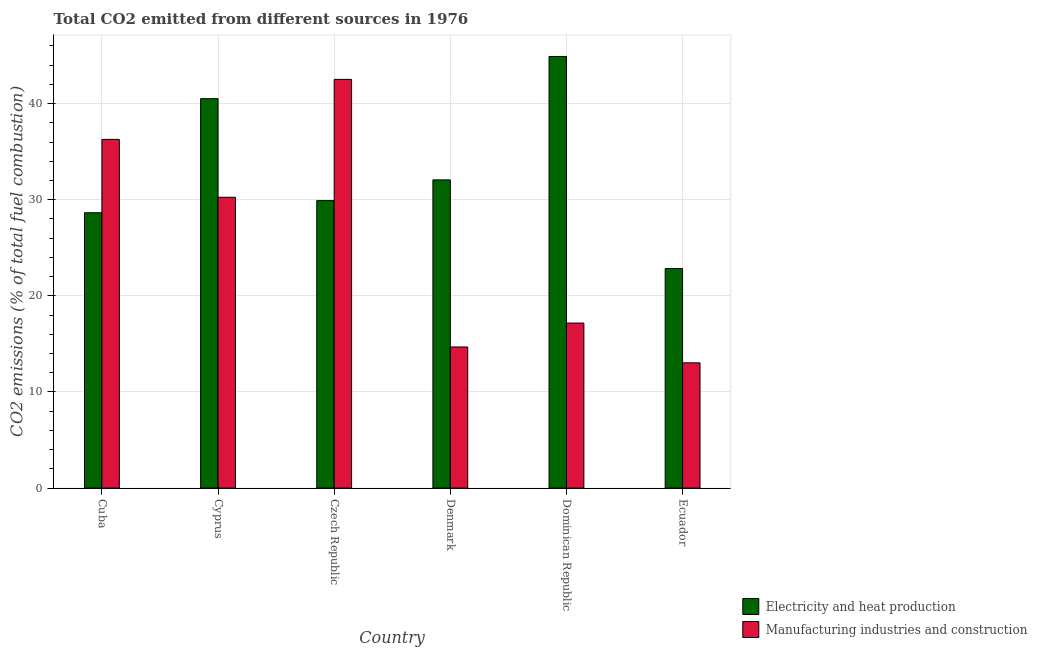How many different coloured bars are there?
Give a very brief answer. 2. How many groups of bars are there?
Ensure brevity in your answer.  6. Are the number of bars per tick equal to the number of legend labels?
Your answer should be compact. Yes. Are the number of bars on each tick of the X-axis equal?
Give a very brief answer. Yes. How many bars are there on the 6th tick from the left?
Offer a very short reply. 2. What is the label of the 4th group of bars from the left?
Your answer should be compact. Denmark. In how many cases, is the number of bars for a given country not equal to the number of legend labels?
Provide a succinct answer. 0. What is the co2 emissions due to electricity and heat production in Cuba?
Ensure brevity in your answer.  28.65. Across all countries, what is the maximum co2 emissions due to manufacturing industries?
Keep it short and to the point. 42.52. Across all countries, what is the minimum co2 emissions due to electricity and heat production?
Keep it short and to the point. 22.84. In which country was the co2 emissions due to electricity and heat production maximum?
Provide a short and direct response. Dominican Republic. In which country was the co2 emissions due to manufacturing industries minimum?
Ensure brevity in your answer.  Ecuador. What is the total co2 emissions due to electricity and heat production in the graph?
Your answer should be compact. 198.88. What is the difference between the co2 emissions due to electricity and heat production in Cyprus and that in Denmark?
Give a very brief answer. 8.45. What is the difference between the co2 emissions due to manufacturing industries in Denmark and the co2 emissions due to electricity and heat production in Dominican Republic?
Provide a short and direct response. -30.22. What is the average co2 emissions due to manufacturing industries per country?
Provide a succinct answer. 25.66. What is the difference between the co2 emissions due to manufacturing industries and co2 emissions due to electricity and heat production in Denmark?
Provide a succinct answer. -17.38. In how many countries, is the co2 emissions due to manufacturing industries greater than 42 %?
Your answer should be very brief. 1. What is the ratio of the co2 emissions due to manufacturing industries in Cyprus to that in Denmark?
Offer a terse response. 2.06. What is the difference between the highest and the second highest co2 emissions due to manufacturing industries?
Offer a very short reply. 6.24. What is the difference between the highest and the lowest co2 emissions due to electricity and heat production?
Your response must be concise. 22.07. What does the 2nd bar from the left in Dominican Republic represents?
Make the answer very short. Manufacturing industries and construction. What does the 1st bar from the right in Cyprus represents?
Your answer should be very brief. Manufacturing industries and construction. Are all the bars in the graph horizontal?
Provide a succinct answer. No. How many countries are there in the graph?
Your response must be concise. 6. What is the difference between two consecutive major ticks on the Y-axis?
Give a very brief answer. 10. Does the graph contain any zero values?
Offer a very short reply. No. Does the graph contain grids?
Offer a very short reply. Yes. Where does the legend appear in the graph?
Provide a short and direct response. Bottom right. How are the legend labels stacked?
Offer a very short reply. Vertical. What is the title of the graph?
Your answer should be compact. Total CO2 emitted from different sources in 1976. What is the label or title of the Y-axis?
Offer a terse response. CO2 emissions (% of total fuel combustion). What is the CO2 emissions (% of total fuel combustion) of Electricity and heat production in Cuba?
Provide a short and direct response. 28.65. What is the CO2 emissions (% of total fuel combustion) in Manufacturing industries and construction in Cuba?
Give a very brief answer. 36.28. What is the CO2 emissions (% of total fuel combustion) of Electricity and heat production in Cyprus?
Your answer should be very brief. 40.51. What is the CO2 emissions (% of total fuel combustion) in Manufacturing industries and construction in Cyprus?
Your answer should be compact. 30.26. What is the CO2 emissions (% of total fuel combustion) of Electricity and heat production in Czech Republic?
Your answer should be very brief. 29.91. What is the CO2 emissions (% of total fuel combustion) in Manufacturing industries and construction in Czech Republic?
Give a very brief answer. 42.52. What is the CO2 emissions (% of total fuel combustion) in Electricity and heat production in Denmark?
Your answer should be compact. 32.07. What is the CO2 emissions (% of total fuel combustion) of Manufacturing industries and construction in Denmark?
Give a very brief answer. 14.68. What is the CO2 emissions (% of total fuel combustion) of Electricity and heat production in Dominican Republic?
Your answer should be very brief. 44.91. What is the CO2 emissions (% of total fuel combustion) in Manufacturing industries and construction in Dominican Republic?
Your answer should be very brief. 17.17. What is the CO2 emissions (% of total fuel combustion) of Electricity and heat production in Ecuador?
Offer a very short reply. 22.84. What is the CO2 emissions (% of total fuel combustion) in Manufacturing industries and construction in Ecuador?
Make the answer very short. 13.03. Across all countries, what is the maximum CO2 emissions (% of total fuel combustion) of Electricity and heat production?
Offer a terse response. 44.91. Across all countries, what is the maximum CO2 emissions (% of total fuel combustion) in Manufacturing industries and construction?
Your answer should be compact. 42.52. Across all countries, what is the minimum CO2 emissions (% of total fuel combustion) of Electricity and heat production?
Provide a short and direct response. 22.84. Across all countries, what is the minimum CO2 emissions (% of total fuel combustion) of Manufacturing industries and construction?
Your answer should be very brief. 13.03. What is the total CO2 emissions (% of total fuel combustion) of Electricity and heat production in the graph?
Offer a very short reply. 198.88. What is the total CO2 emissions (% of total fuel combustion) in Manufacturing industries and construction in the graph?
Your answer should be very brief. 153.94. What is the difference between the CO2 emissions (% of total fuel combustion) of Electricity and heat production in Cuba and that in Cyprus?
Your answer should be very brief. -11.87. What is the difference between the CO2 emissions (% of total fuel combustion) in Manufacturing industries and construction in Cuba and that in Cyprus?
Ensure brevity in your answer.  6.02. What is the difference between the CO2 emissions (% of total fuel combustion) of Electricity and heat production in Cuba and that in Czech Republic?
Give a very brief answer. -1.26. What is the difference between the CO2 emissions (% of total fuel combustion) in Manufacturing industries and construction in Cuba and that in Czech Republic?
Your response must be concise. -6.24. What is the difference between the CO2 emissions (% of total fuel combustion) of Electricity and heat production in Cuba and that in Denmark?
Your answer should be very brief. -3.42. What is the difference between the CO2 emissions (% of total fuel combustion) of Manufacturing industries and construction in Cuba and that in Denmark?
Provide a succinct answer. 21.6. What is the difference between the CO2 emissions (% of total fuel combustion) in Electricity and heat production in Cuba and that in Dominican Republic?
Make the answer very short. -16.26. What is the difference between the CO2 emissions (% of total fuel combustion) of Manufacturing industries and construction in Cuba and that in Dominican Republic?
Your answer should be very brief. 19.11. What is the difference between the CO2 emissions (% of total fuel combustion) in Electricity and heat production in Cuba and that in Ecuador?
Ensure brevity in your answer.  5.81. What is the difference between the CO2 emissions (% of total fuel combustion) of Manufacturing industries and construction in Cuba and that in Ecuador?
Provide a succinct answer. 23.25. What is the difference between the CO2 emissions (% of total fuel combustion) of Electricity and heat production in Cyprus and that in Czech Republic?
Keep it short and to the point. 10.61. What is the difference between the CO2 emissions (% of total fuel combustion) in Manufacturing industries and construction in Cyprus and that in Czech Republic?
Provide a succinct answer. -12.26. What is the difference between the CO2 emissions (% of total fuel combustion) of Electricity and heat production in Cyprus and that in Denmark?
Your answer should be compact. 8.45. What is the difference between the CO2 emissions (% of total fuel combustion) of Manufacturing industries and construction in Cyprus and that in Denmark?
Your answer should be very brief. 15.57. What is the difference between the CO2 emissions (% of total fuel combustion) of Electricity and heat production in Cyprus and that in Dominican Republic?
Offer a very short reply. -4.39. What is the difference between the CO2 emissions (% of total fuel combustion) in Manufacturing industries and construction in Cyprus and that in Dominican Republic?
Ensure brevity in your answer.  13.09. What is the difference between the CO2 emissions (% of total fuel combustion) in Electricity and heat production in Cyprus and that in Ecuador?
Offer a terse response. 17.67. What is the difference between the CO2 emissions (% of total fuel combustion) of Manufacturing industries and construction in Cyprus and that in Ecuador?
Provide a succinct answer. 17.23. What is the difference between the CO2 emissions (% of total fuel combustion) of Electricity and heat production in Czech Republic and that in Denmark?
Your response must be concise. -2.16. What is the difference between the CO2 emissions (% of total fuel combustion) in Manufacturing industries and construction in Czech Republic and that in Denmark?
Offer a terse response. 27.84. What is the difference between the CO2 emissions (% of total fuel combustion) in Electricity and heat production in Czech Republic and that in Dominican Republic?
Provide a succinct answer. -15. What is the difference between the CO2 emissions (% of total fuel combustion) in Manufacturing industries and construction in Czech Republic and that in Dominican Republic?
Offer a very short reply. 25.35. What is the difference between the CO2 emissions (% of total fuel combustion) of Electricity and heat production in Czech Republic and that in Ecuador?
Offer a very short reply. 7.07. What is the difference between the CO2 emissions (% of total fuel combustion) in Manufacturing industries and construction in Czech Republic and that in Ecuador?
Offer a terse response. 29.49. What is the difference between the CO2 emissions (% of total fuel combustion) of Electricity and heat production in Denmark and that in Dominican Republic?
Make the answer very short. -12.84. What is the difference between the CO2 emissions (% of total fuel combustion) of Manufacturing industries and construction in Denmark and that in Dominican Republic?
Provide a succinct answer. -2.49. What is the difference between the CO2 emissions (% of total fuel combustion) of Electricity and heat production in Denmark and that in Ecuador?
Keep it short and to the point. 9.22. What is the difference between the CO2 emissions (% of total fuel combustion) in Manufacturing industries and construction in Denmark and that in Ecuador?
Provide a succinct answer. 1.65. What is the difference between the CO2 emissions (% of total fuel combustion) in Electricity and heat production in Dominican Republic and that in Ecuador?
Your answer should be compact. 22.07. What is the difference between the CO2 emissions (% of total fuel combustion) of Manufacturing industries and construction in Dominican Republic and that in Ecuador?
Ensure brevity in your answer.  4.14. What is the difference between the CO2 emissions (% of total fuel combustion) of Electricity and heat production in Cuba and the CO2 emissions (% of total fuel combustion) of Manufacturing industries and construction in Cyprus?
Give a very brief answer. -1.61. What is the difference between the CO2 emissions (% of total fuel combustion) in Electricity and heat production in Cuba and the CO2 emissions (% of total fuel combustion) in Manufacturing industries and construction in Czech Republic?
Offer a very short reply. -13.87. What is the difference between the CO2 emissions (% of total fuel combustion) of Electricity and heat production in Cuba and the CO2 emissions (% of total fuel combustion) of Manufacturing industries and construction in Denmark?
Provide a succinct answer. 13.96. What is the difference between the CO2 emissions (% of total fuel combustion) of Electricity and heat production in Cuba and the CO2 emissions (% of total fuel combustion) of Manufacturing industries and construction in Dominican Republic?
Provide a short and direct response. 11.48. What is the difference between the CO2 emissions (% of total fuel combustion) of Electricity and heat production in Cuba and the CO2 emissions (% of total fuel combustion) of Manufacturing industries and construction in Ecuador?
Your response must be concise. 15.62. What is the difference between the CO2 emissions (% of total fuel combustion) of Electricity and heat production in Cyprus and the CO2 emissions (% of total fuel combustion) of Manufacturing industries and construction in Czech Republic?
Your response must be concise. -2.01. What is the difference between the CO2 emissions (% of total fuel combustion) in Electricity and heat production in Cyprus and the CO2 emissions (% of total fuel combustion) in Manufacturing industries and construction in Denmark?
Your answer should be very brief. 25.83. What is the difference between the CO2 emissions (% of total fuel combustion) of Electricity and heat production in Cyprus and the CO2 emissions (% of total fuel combustion) of Manufacturing industries and construction in Dominican Republic?
Offer a terse response. 23.34. What is the difference between the CO2 emissions (% of total fuel combustion) in Electricity and heat production in Cyprus and the CO2 emissions (% of total fuel combustion) in Manufacturing industries and construction in Ecuador?
Ensure brevity in your answer.  27.48. What is the difference between the CO2 emissions (% of total fuel combustion) in Electricity and heat production in Czech Republic and the CO2 emissions (% of total fuel combustion) in Manufacturing industries and construction in Denmark?
Provide a short and direct response. 15.22. What is the difference between the CO2 emissions (% of total fuel combustion) of Electricity and heat production in Czech Republic and the CO2 emissions (% of total fuel combustion) of Manufacturing industries and construction in Dominican Republic?
Provide a short and direct response. 12.74. What is the difference between the CO2 emissions (% of total fuel combustion) of Electricity and heat production in Czech Republic and the CO2 emissions (% of total fuel combustion) of Manufacturing industries and construction in Ecuador?
Your answer should be compact. 16.88. What is the difference between the CO2 emissions (% of total fuel combustion) in Electricity and heat production in Denmark and the CO2 emissions (% of total fuel combustion) in Manufacturing industries and construction in Dominican Republic?
Your answer should be compact. 14.9. What is the difference between the CO2 emissions (% of total fuel combustion) of Electricity and heat production in Denmark and the CO2 emissions (% of total fuel combustion) of Manufacturing industries and construction in Ecuador?
Your answer should be very brief. 19.03. What is the difference between the CO2 emissions (% of total fuel combustion) of Electricity and heat production in Dominican Republic and the CO2 emissions (% of total fuel combustion) of Manufacturing industries and construction in Ecuador?
Your answer should be very brief. 31.87. What is the average CO2 emissions (% of total fuel combustion) in Electricity and heat production per country?
Make the answer very short. 33.15. What is the average CO2 emissions (% of total fuel combustion) in Manufacturing industries and construction per country?
Keep it short and to the point. 25.66. What is the difference between the CO2 emissions (% of total fuel combustion) of Electricity and heat production and CO2 emissions (% of total fuel combustion) of Manufacturing industries and construction in Cuba?
Give a very brief answer. -7.63. What is the difference between the CO2 emissions (% of total fuel combustion) in Electricity and heat production and CO2 emissions (% of total fuel combustion) in Manufacturing industries and construction in Cyprus?
Ensure brevity in your answer.  10.26. What is the difference between the CO2 emissions (% of total fuel combustion) of Electricity and heat production and CO2 emissions (% of total fuel combustion) of Manufacturing industries and construction in Czech Republic?
Your response must be concise. -12.61. What is the difference between the CO2 emissions (% of total fuel combustion) of Electricity and heat production and CO2 emissions (% of total fuel combustion) of Manufacturing industries and construction in Denmark?
Ensure brevity in your answer.  17.38. What is the difference between the CO2 emissions (% of total fuel combustion) in Electricity and heat production and CO2 emissions (% of total fuel combustion) in Manufacturing industries and construction in Dominican Republic?
Ensure brevity in your answer.  27.74. What is the difference between the CO2 emissions (% of total fuel combustion) in Electricity and heat production and CO2 emissions (% of total fuel combustion) in Manufacturing industries and construction in Ecuador?
Make the answer very short. 9.81. What is the ratio of the CO2 emissions (% of total fuel combustion) in Electricity and heat production in Cuba to that in Cyprus?
Keep it short and to the point. 0.71. What is the ratio of the CO2 emissions (% of total fuel combustion) of Manufacturing industries and construction in Cuba to that in Cyprus?
Make the answer very short. 1.2. What is the ratio of the CO2 emissions (% of total fuel combustion) in Electricity and heat production in Cuba to that in Czech Republic?
Make the answer very short. 0.96. What is the ratio of the CO2 emissions (% of total fuel combustion) in Manufacturing industries and construction in Cuba to that in Czech Republic?
Your answer should be compact. 0.85. What is the ratio of the CO2 emissions (% of total fuel combustion) in Electricity and heat production in Cuba to that in Denmark?
Keep it short and to the point. 0.89. What is the ratio of the CO2 emissions (% of total fuel combustion) in Manufacturing industries and construction in Cuba to that in Denmark?
Offer a terse response. 2.47. What is the ratio of the CO2 emissions (% of total fuel combustion) of Electricity and heat production in Cuba to that in Dominican Republic?
Provide a short and direct response. 0.64. What is the ratio of the CO2 emissions (% of total fuel combustion) in Manufacturing industries and construction in Cuba to that in Dominican Republic?
Make the answer very short. 2.11. What is the ratio of the CO2 emissions (% of total fuel combustion) in Electricity and heat production in Cuba to that in Ecuador?
Your answer should be very brief. 1.25. What is the ratio of the CO2 emissions (% of total fuel combustion) in Manufacturing industries and construction in Cuba to that in Ecuador?
Provide a short and direct response. 2.78. What is the ratio of the CO2 emissions (% of total fuel combustion) of Electricity and heat production in Cyprus to that in Czech Republic?
Give a very brief answer. 1.35. What is the ratio of the CO2 emissions (% of total fuel combustion) in Manufacturing industries and construction in Cyprus to that in Czech Republic?
Make the answer very short. 0.71. What is the ratio of the CO2 emissions (% of total fuel combustion) in Electricity and heat production in Cyprus to that in Denmark?
Offer a very short reply. 1.26. What is the ratio of the CO2 emissions (% of total fuel combustion) in Manufacturing industries and construction in Cyprus to that in Denmark?
Ensure brevity in your answer.  2.06. What is the ratio of the CO2 emissions (% of total fuel combustion) in Electricity and heat production in Cyprus to that in Dominican Republic?
Make the answer very short. 0.9. What is the ratio of the CO2 emissions (% of total fuel combustion) of Manufacturing industries and construction in Cyprus to that in Dominican Republic?
Provide a short and direct response. 1.76. What is the ratio of the CO2 emissions (% of total fuel combustion) in Electricity and heat production in Cyprus to that in Ecuador?
Ensure brevity in your answer.  1.77. What is the ratio of the CO2 emissions (% of total fuel combustion) of Manufacturing industries and construction in Cyprus to that in Ecuador?
Offer a very short reply. 2.32. What is the ratio of the CO2 emissions (% of total fuel combustion) in Electricity and heat production in Czech Republic to that in Denmark?
Offer a very short reply. 0.93. What is the ratio of the CO2 emissions (% of total fuel combustion) in Manufacturing industries and construction in Czech Republic to that in Denmark?
Offer a very short reply. 2.9. What is the ratio of the CO2 emissions (% of total fuel combustion) of Electricity and heat production in Czech Republic to that in Dominican Republic?
Provide a short and direct response. 0.67. What is the ratio of the CO2 emissions (% of total fuel combustion) of Manufacturing industries and construction in Czech Republic to that in Dominican Republic?
Offer a terse response. 2.48. What is the ratio of the CO2 emissions (% of total fuel combustion) in Electricity and heat production in Czech Republic to that in Ecuador?
Give a very brief answer. 1.31. What is the ratio of the CO2 emissions (% of total fuel combustion) of Manufacturing industries and construction in Czech Republic to that in Ecuador?
Your answer should be compact. 3.26. What is the ratio of the CO2 emissions (% of total fuel combustion) in Electricity and heat production in Denmark to that in Dominican Republic?
Your answer should be very brief. 0.71. What is the ratio of the CO2 emissions (% of total fuel combustion) in Manufacturing industries and construction in Denmark to that in Dominican Republic?
Your answer should be compact. 0.86. What is the ratio of the CO2 emissions (% of total fuel combustion) in Electricity and heat production in Denmark to that in Ecuador?
Offer a terse response. 1.4. What is the ratio of the CO2 emissions (% of total fuel combustion) in Manufacturing industries and construction in Denmark to that in Ecuador?
Provide a succinct answer. 1.13. What is the ratio of the CO2 emissions (% of total fuel combustion) in Electricity and heat production in Dominican Republic to that in Ecuador?
Your response must be concise. 1.97. What is the ratio of the CO2 emissions (% of total fuel combustion) of Manufacturing industries and construction in Dominican Republic to that in Ecuador?
Give a very brief answer. 1.32. What is the difference between the highest and the second highest CO2 emissions (% of total fuel combustion) in Electricity and heat production?
Your answer should be compact. 4.39. What is the difference between the highest and the second highest CO2 emissions (% of total fuel combustion) in Manufacturing industries and construction?
Offer a terse response. 6.24. What is the difference between the highest and the lowest CO2 emissions (% of total fuel combustion) in Electricity and heat production?
Your answer should be very brief. 22.07. What is the difference between the highest and the lowest CO2 emissions (% of total fuel combustion) of Manufacturing industries and construction?
Ensure brevity in your answer.  29.49. 